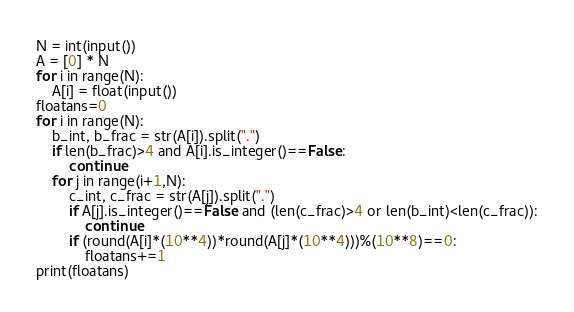Convert code to text. <code><loc_0><loc_0><loc_500><loc_500><_Python_>N = int(input())
A = [0] * N
for i in range(N):
    A[i] = float(input())
floatans=0
for i in range(N):
    b_int, b_frac = str(A[i]).split(".")
    if len(b_frac)>4 and A[i].is_integer()==False:
        continue
    for j in range(i+1,N):
        c_int, c_frac = str(A[j]).split(".")
        if A[j].is_integer()==False and (len(c_frac)>4 or len(b_int)<len(c_frac)):
            continue
        if (round(A[i]*(10**4))*round(A[j]*(10**4)))%(10**8)==0:
            floatans+=1
print(floatans)</code> 